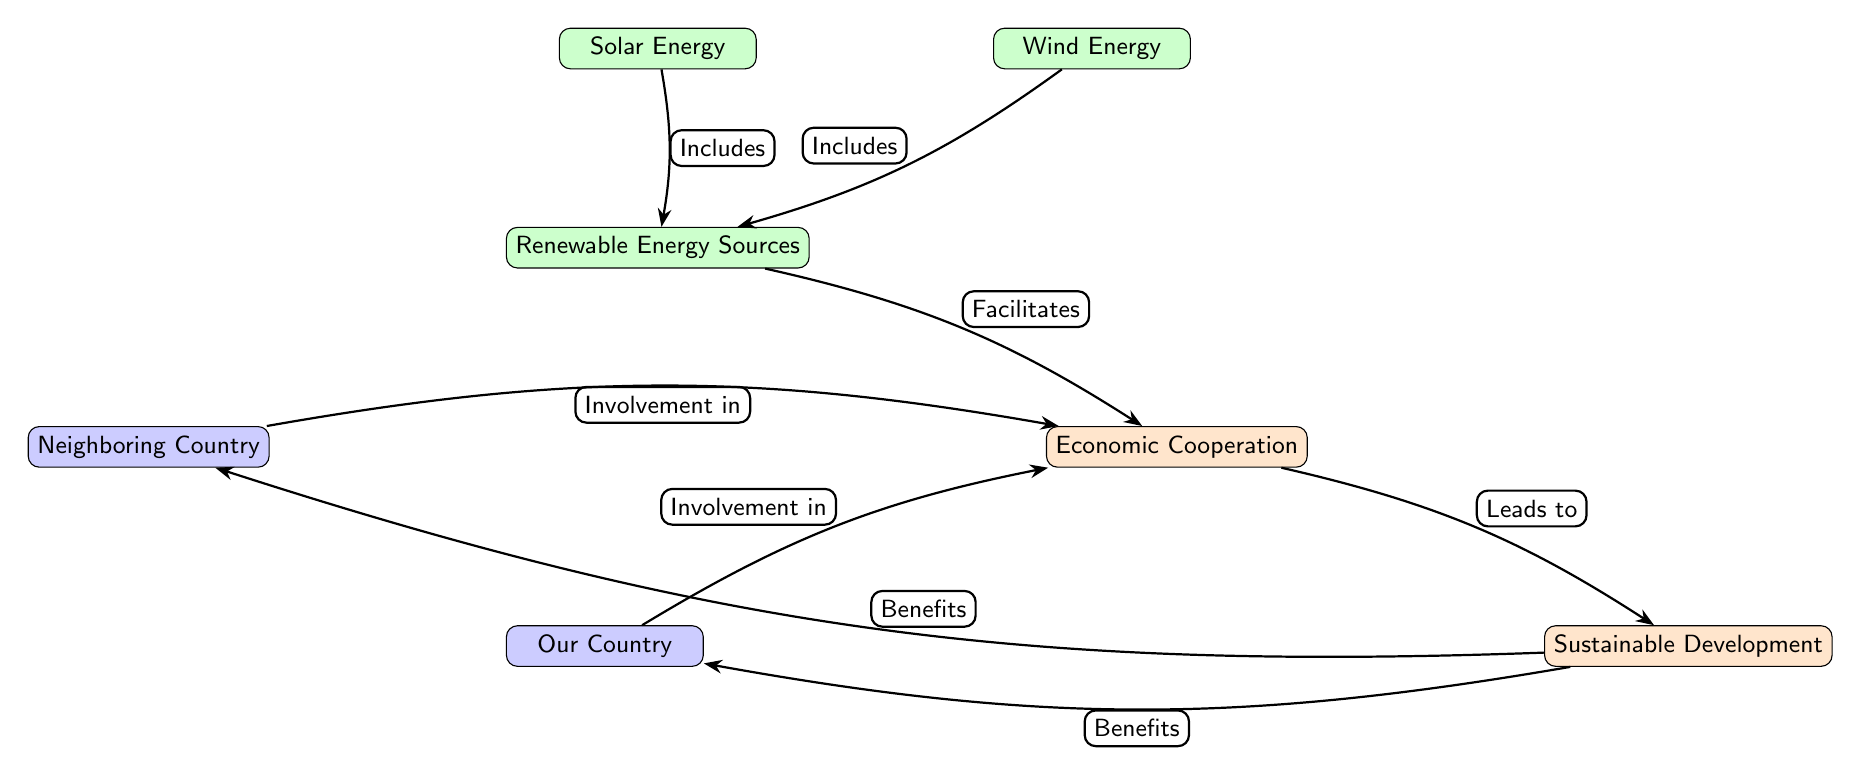What are the two countries represented in the diagram? The diagram includes two countries labeled as "Neighboring Country" and "Our Country." This information is depicted in the two nodes representing countries, respectively.
Answer: Neighboring Country, Our Country What energy sources are included under Renewable Energy Sources? The diagram lists two specific renewable energy sources: "Solar Energy" and "Wind Energy." This is identified through the connections from the Renewable Energy Sources node.
Answer: Solar Energy, Wind Energy How many nodes are present in the diagram? By counting all distinct elements represented in the diagram, there are a total of six nodes: two countries, two energy sources, one economic concept, and one sustainable development concept.
Answer: Six Which node leads to Sustainable Development? The "Economic Cooperation" node has a direct connection labeled "Leads to" the "Sustainable Development" node. Thus, Economic Cooperation is the one that leads to Sustainable Development.
Answer: Economic Cooperation What do both countries have an involvement in? The diagram shows that both the "Neighboring Country" and "Our Country" have an involvement in "Economic Cooperation," as indicated by their respective connections to this concept.
Answer: Economic Cooperation How does Renewable Energy Resources impact the Economic Cooperation? Renewable Energy Sources are shown to "Facilitate" Economic Cooperation in the diagram, highlighting the positive influence renewable energies have on economic interactions between the countries.
Answer: Facilitates Which renewable energy source is positioned to the right in the diagram? In the diagram, "Wind Energy" is positioned to the right of "Solar Energy," indicating that it is the second renewable energy source when viewed horizontally.
Answer: Wind Energy Which node benefits the Neighboring Country? According to the diagram, the "Sustainable Development" node is connected with a label stating "Benefits" to the "Neighboring Country," indicating this is the source of benefits.
Answer: Sustainable Development What is the relationship between Sustainable Development and the Neighboring Country? The relationship is defined in the diagram where "Sustainable Development" directly benefits the "Neighboring Country." This is illustrated with a clear connection marked by "Benefits."
Answer: Benefits 